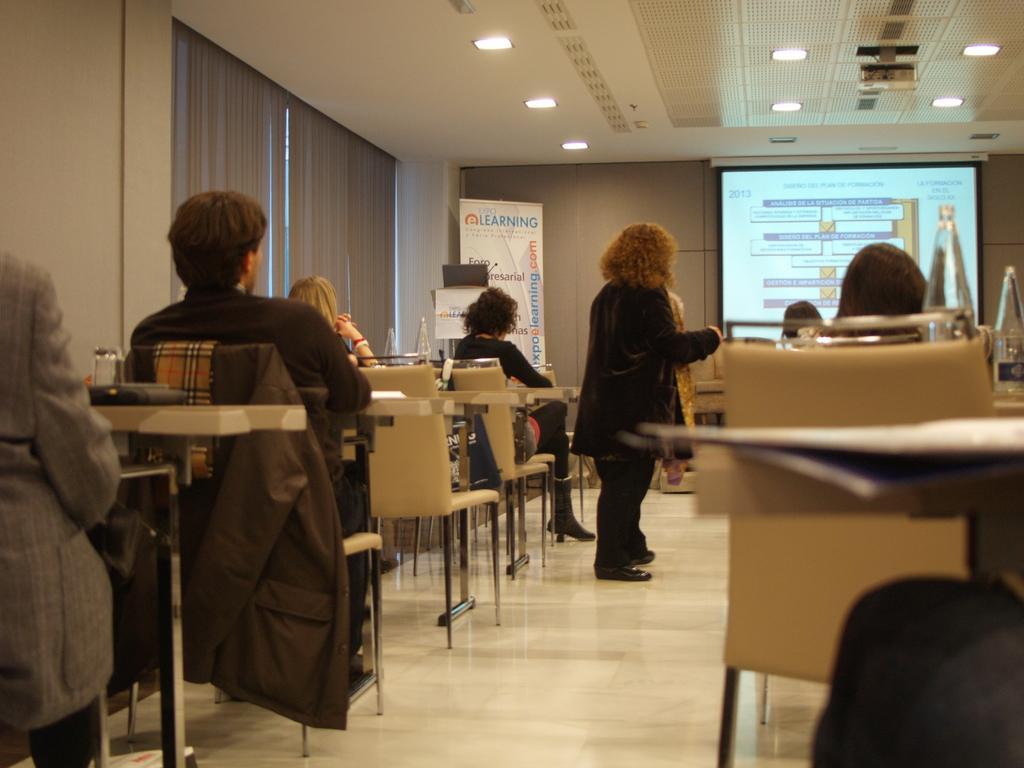Can you describe this image briefly? This picture shows a group of people seated on the chair and we see a projector screen and woman standing 